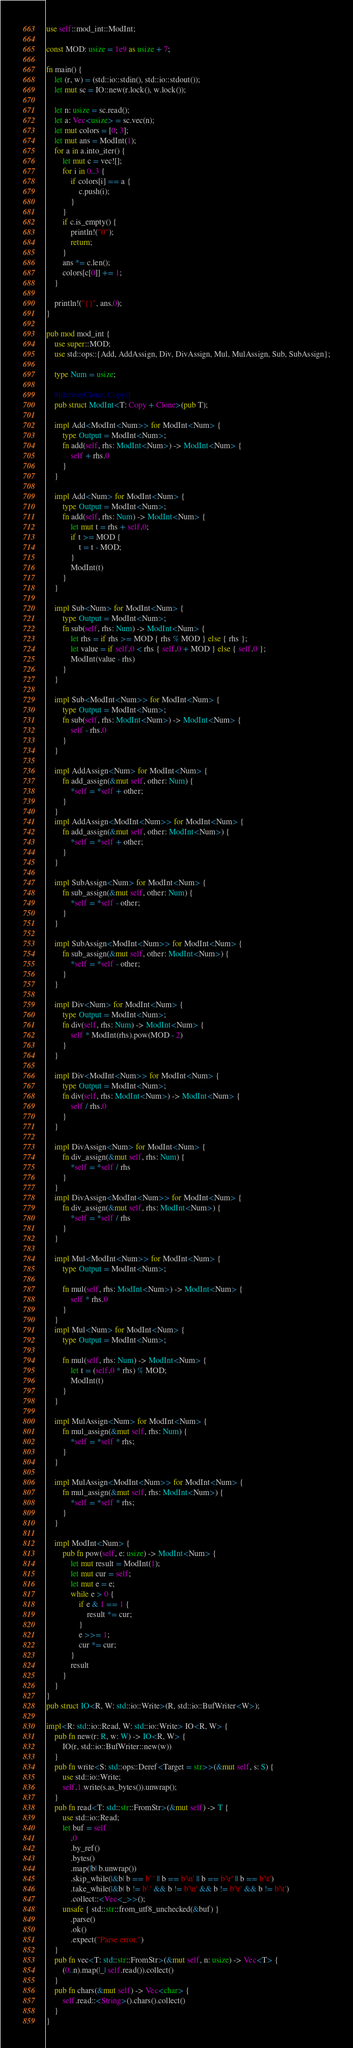Convert code to text. <code><loc_0><loc_0><loc_500><loc_500><_Rust_>use self::mod_int::ModInt;

const MOD: usize = 1e9 as usize + 7;

fn main() {
    let (r, w) = (std::io::stdin(), std::io::stdout());
    let mut sc = IO::new(r.lock(), w.lock());

    let n: usize = sc.read();
    let a: Vec<usize> = sc.vec(n);
    let mut colors = [0; 3];
    let mut ans = ModInt(1);
    for a in a.into_iter() {
        let mut c = vec![];
        for i in 0..3 {
            if colors[i] == a {
                c.push(i);
            }
        }
        if c.is_empty() {
            println!("0");
            return;
        }
        ans *= c.len();
        colors[c[0]] += 1;
    }

    println!("{}", ans.0);
}

pub mod mod_int {
    use super::MOD;
    use std::ops::{Add, AddAssign, Div, DivAssign, Mul, MulAssign, Sub, SubAssign};

    type Num = usize;

    #[derive(Clone, Copy)]
    pub struct ModInt<T: Copy + Clone>(pub T);

    impl Add<ModInt<Num>> for ModInt<Num> {
        type Output = ModInt<Num>;
        fn add(self, rhs: ModInt<Num>) -> ModInt<Num> {
            self + rhs.0
        }
    }

    impl Add<Num> for ModInt<Num> {
        type Output = ModInt<Num>;
        fn add(self, rhs: Num) -> ModInt<Num> {
            let mut t = rhs + self.0;
            if t >= MOD {
                t = t - MOD;
            }
            ModInt(t)
        }
    }

    impl Sub<Num> for ModInt<Num> {
        type Output = ModInt<Num>;
        fn sub(self, rhs: Num) -> ModInt<Num> {
            let rhs = if rhs >= MOD { rhs % MOD } else { rhs };
            let value = if self.0 < rhs { self.0 + MOD } else { self.0 };
            ModInt(value - rhs)
        }
    }

    impl Sub<ModInt<Num>> for ModInt<Num> {
        type Output = ModInt<Num>;
        fn sub(self, rhs: ModInt<Num>) -> ModInt<Num> {
            self - rhs.0
        }
    }

    impl AddAssign<Num> for ModInt<Num> {
        fn add_assign(&mut self, other: Num) {
            *self = *self + other;
        }
    }
    impl AddAssign<ModInt<Num>> for ModInt<Num> {
        fn add_assign(&mut self, other: ModInt<Num>) {
            *self = *self + other;
        }
    }

    impl SubAssign<Num> for ModInt<Num> {
        fn sub_assign(&mut self, other: Num) {
            *self = *self - other;
        }
    }

    impl SubAssign<ModInt<Num>> for ModInt<Num> {
        fn sub_assign(&mut self, other: ModInt<Num>) {
            *self = *self - other;
        }
    }

    impl Div<Num> for ModInt<Num> {
        type Output = ModInt<Num>;
        fn div(self, rhs: Num) -> ModInt<Num> {
            self * ModInt(rhs).pow(MOD - 2)
        }
    }

    impl Div<ModInt<Num>> for ModInt<Num> {
        type Output = ModInt<Num>;
        fn div(self, rhs: ModInt<Num>) -> ModInt<Num> {
            self / rhs.0
        }
    }

    impl DivAssign<Num> for ModInt<Num> {
        fn div_assign(&mut self, rhs: Num) {
            *self = *self / rhs
        }
    }
    impl DivAssign<ModInt<Num>> for ModInt<Num> {
        fn div_assign(&mut self, rhs: ModInt<Num>) {
            *self = *self / rhs
        }
    }

    impl Mul<ModInt<Num>> for ModInt<Num> {
        type Output = ModInt<Num>;

        fn mul(self, rhs: ModInt<Num>) -> ModInt<Num> {
            self * rhs.0
        }
    }
    impl Mul<Num> for ModInt<Num> {
        type Output = ModInt<Num>;

        fn mul(self, rhs: Num) -> ModInt<Num> {
            let t = (self.0 * rhs) % MOD;
            ModInt(t)
        }
    }

    impl MulAssign<Num> for ModInt<Num> {
        fn mul_assign(&mut self, rhs: Num) {
            *self = *self * rhs;
        }
    }

    impl MulAssign<ModInt<Num>> for ModInt<Num> {
        fn mul_assign(&mut self, rhs: ModInt<Num>) {
            *self = *self * rhs;
        }
    }

    impl ModInt<Num> {
        pub fn pow(self, e: usize) -> ModInt<Num> {
            let mut result = ModInt(1);
            let mut cur = self;
            let mut e = e;
            while e > 0 {
                if e & 1 == 1 {
                    result *= cur;
                }
                e >>= 1;
                cur *= cur;
            }
            result
        }
    }
}
pub struct IO<R, W: std::io::Write>(R, std::io::BufWriter<W>);

impl<R: std::io::Read, W: std::io::Write> IO<R, W> {
    pub fn new(r: R, w: W) -> IO<R, W> {
        IO(r, std::io::BufWriter::new(w))
    }
    pub fn write<S: std::ops::Deref<Target = str>>(&mut self, s: S) {
        use std::io::Write;
        self.1.write(s.as_bytes()).unwrap();
    }
    pub fn read<T: std::str::FromStr>(&mut self) -> T {
        use std::io::Read;
        let buf = self
            .0
            .by_ref()
            .bytes()
            .map(|b| b.unwrap())
            .skip_while(|&b| b == b' ' || b == b'\n' || b == b'\r' || b == b'\t')
            .take_while(|&b| b != b' ' && b != b'\n' && b != b'\r' && b != b'\t')
            .collect::<Vec<_>>();
        unsafe { std::str::from_utf8_unchecked(&buf) }
            .parse()
            .ok()
            .expect("Parse error.")
    }
    pub fn vec<T: std::str::FromStr>(&mut self, n: usize) -> Vec<T> {
        (0..n).map(|_| self.read()).collect()
    }
    pub fn chars(&mut self) -> Vec<char> {
        self.read::<String>().chars().collect()
    }
}
</code> 